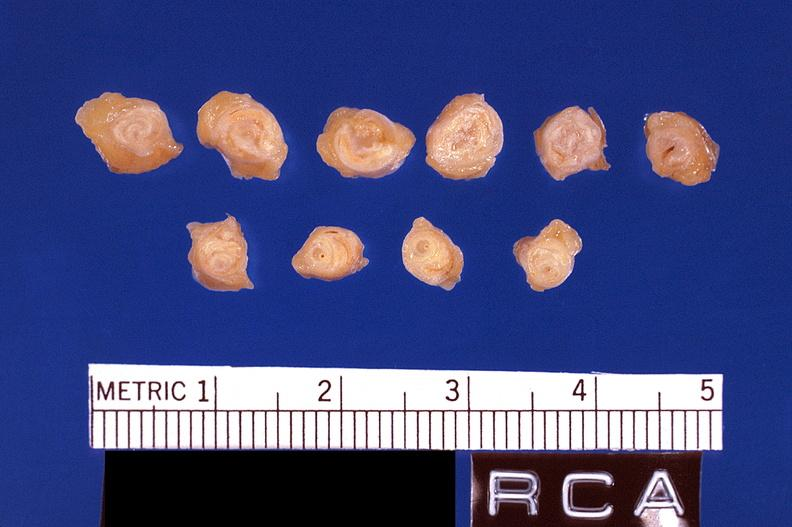s opened muscle present?
Answer the question using a single word or phrase. No 